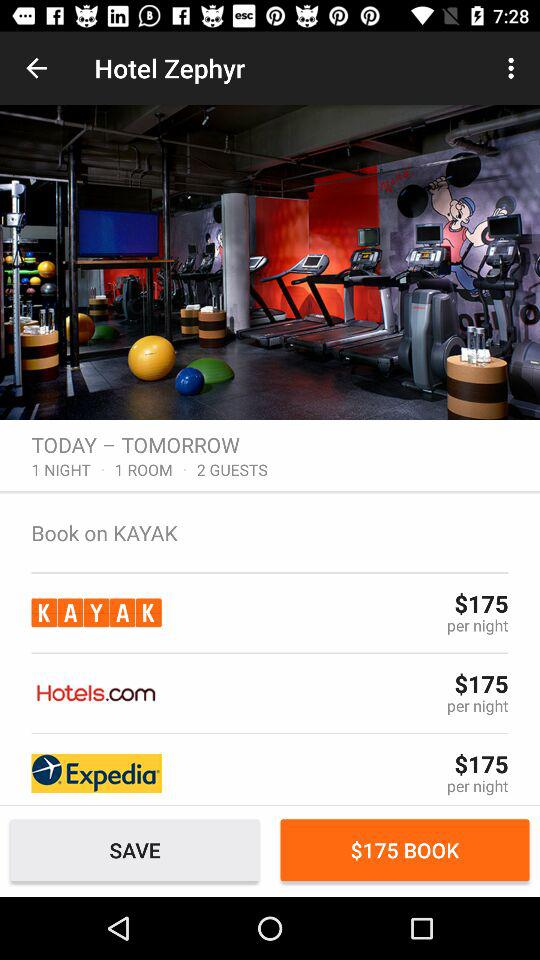What is the number of guests? The number of guests is 2. 